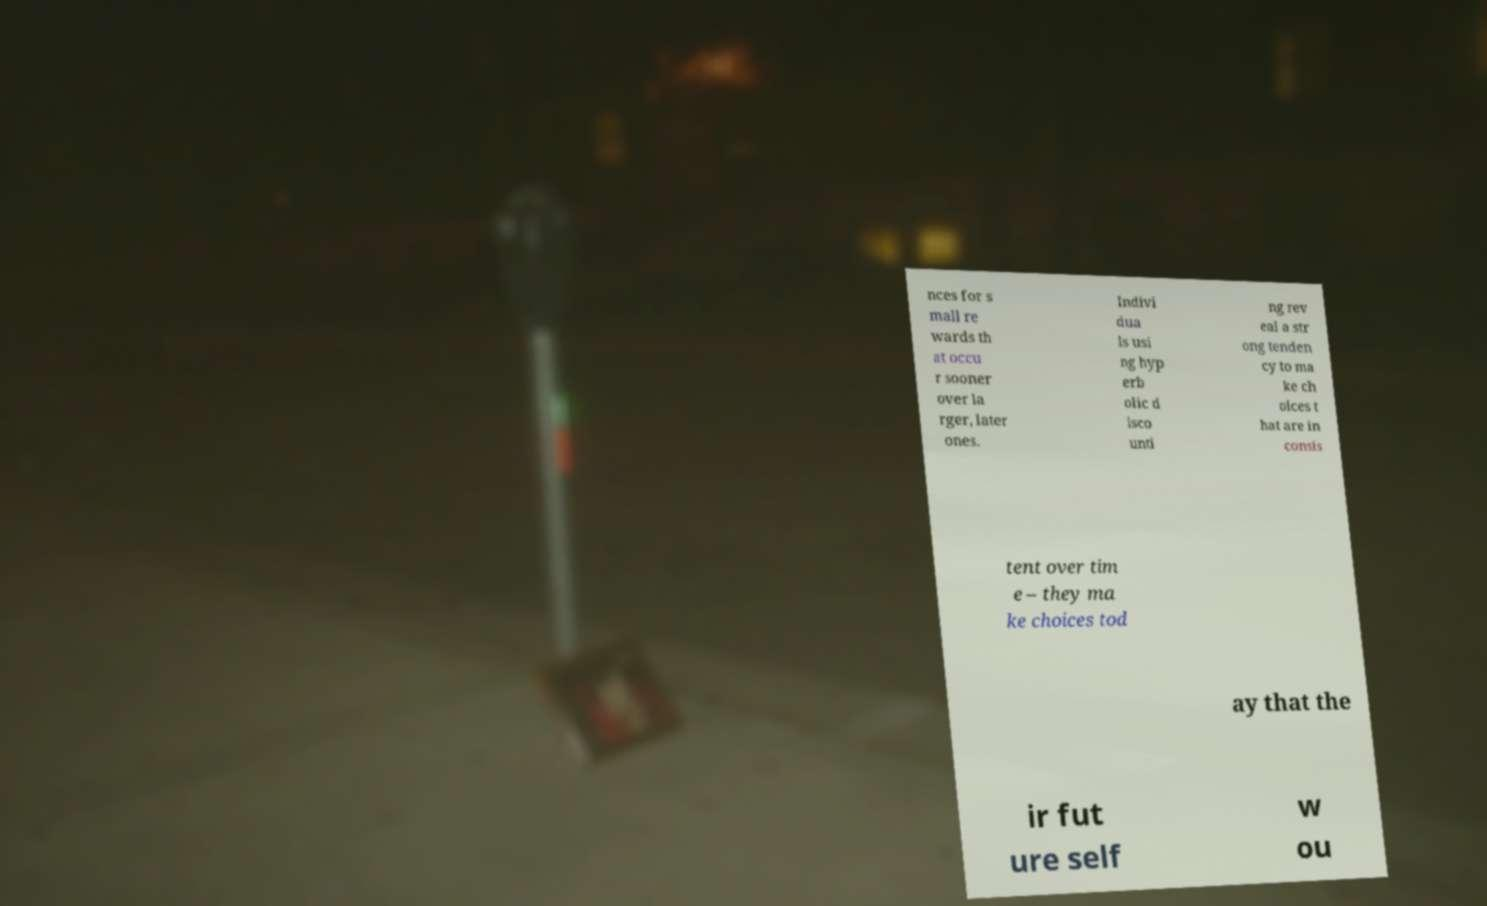For documentation purposes, I need the text within this image transcribed. Could you provide that? nces for s mall re wards th at occu r sooner over la rger, later ones. Indivi dua ls usi ng hyp erb olic d isco unti ng rev eal a str ong tenden cy to ma ke ch oices t hat are in consis tent over tim e – they ma ke choices tod ay that the ir fut ure self w ou 